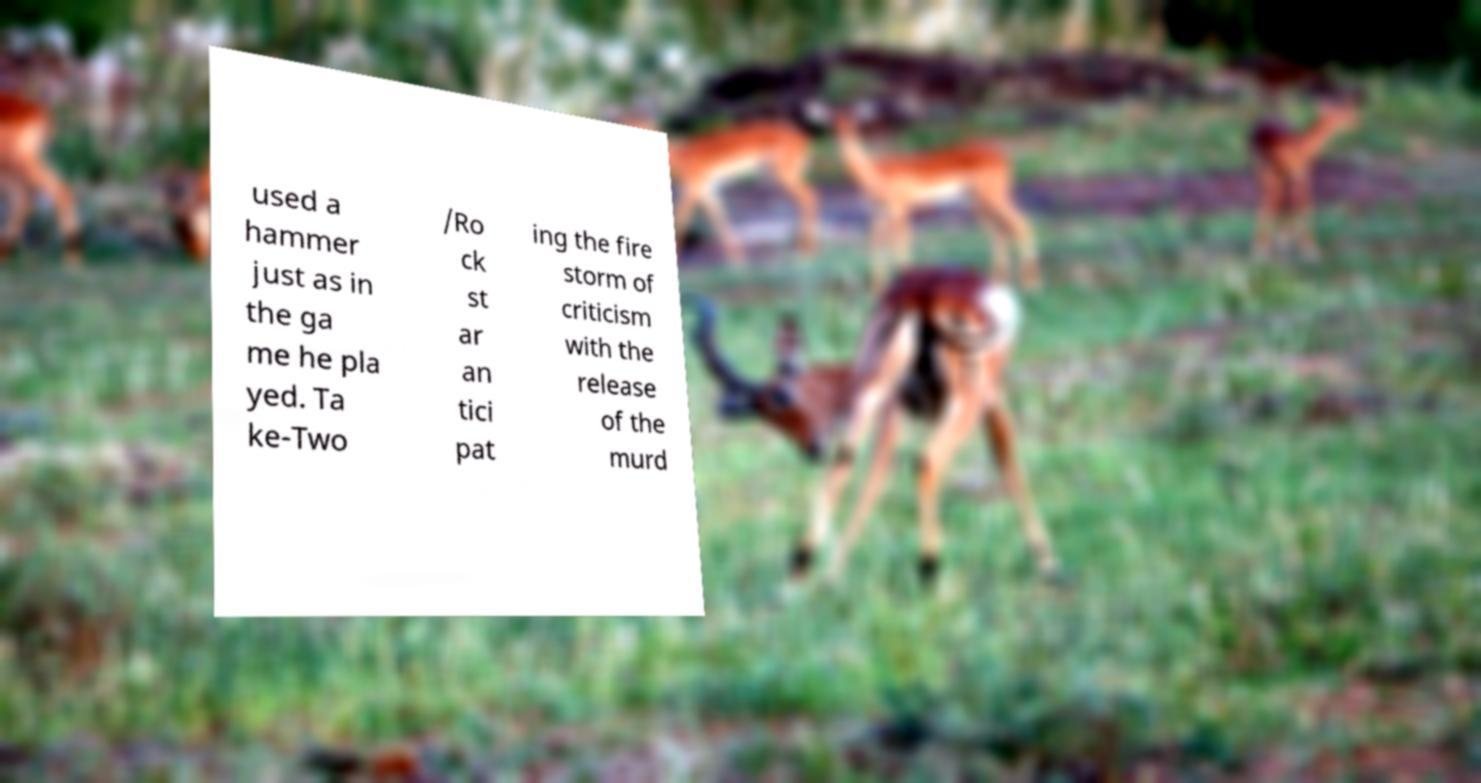I need the written content from this picture converted into text. Can you do that? used a hammer just as in the ga me he pla yed. Ta ke-Two /Ro ck st ar an tici pat ing the fire storm of criticism with the release of the murd 